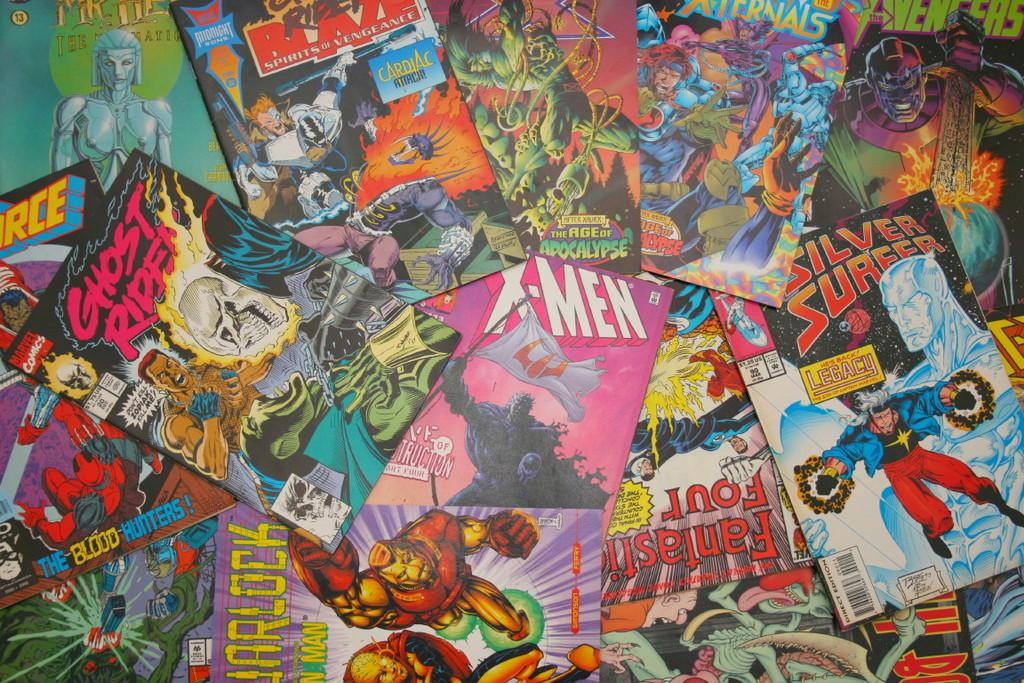Provide a one-sentence caption for the provided image. the x men comic is in the middle of the mess. 